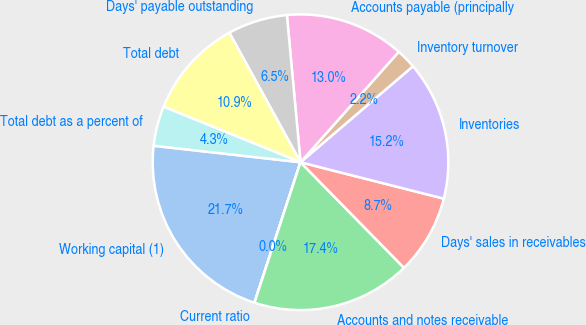<chart> <loc_0><loc_0><loc_500><loc_500><pie_chart><fcel>Working capital (1)<fcel>Current ratio<fcel>Accounts and notes receivable<fcel>Days' sales in receivables<fcel>Inventories<fcel>Inventory turnover<fcel>Accounts payable (principally<fcel>Days' payable outstanding<fcel>Total debt<fcel>Total debt as a percent of<nl><fcel>21.73%<fcel>0.01%<fcel>17.38%<fcel>8.7%<fcel>15.21%<fcel>2.18%<fcel>13.04%<fcel>6.53%<fcel>10.87%<fcel>4.35%<nl></chart> 